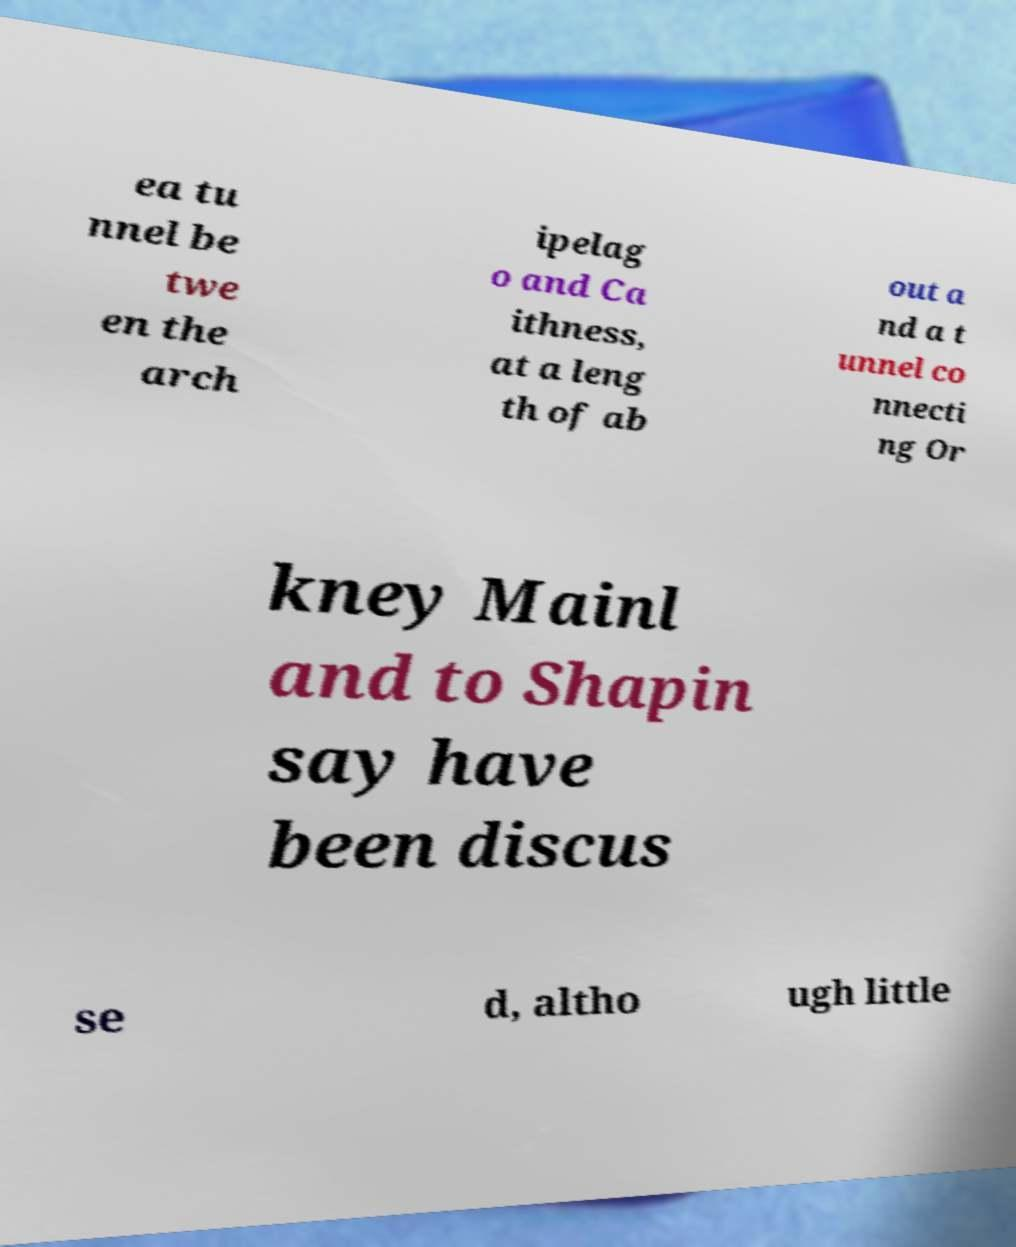Can you read and provide the text displayed in the image?This photo seems to have some interesting text. Can you extract and type it out for me? ea tu nnel be twe en the arch ipelag o and Ca ithness, at a leng th of ab out a nd a t unnel co nnecti ng Or kney Mainl and to Shapin say have been discus se d, altho ugh little 